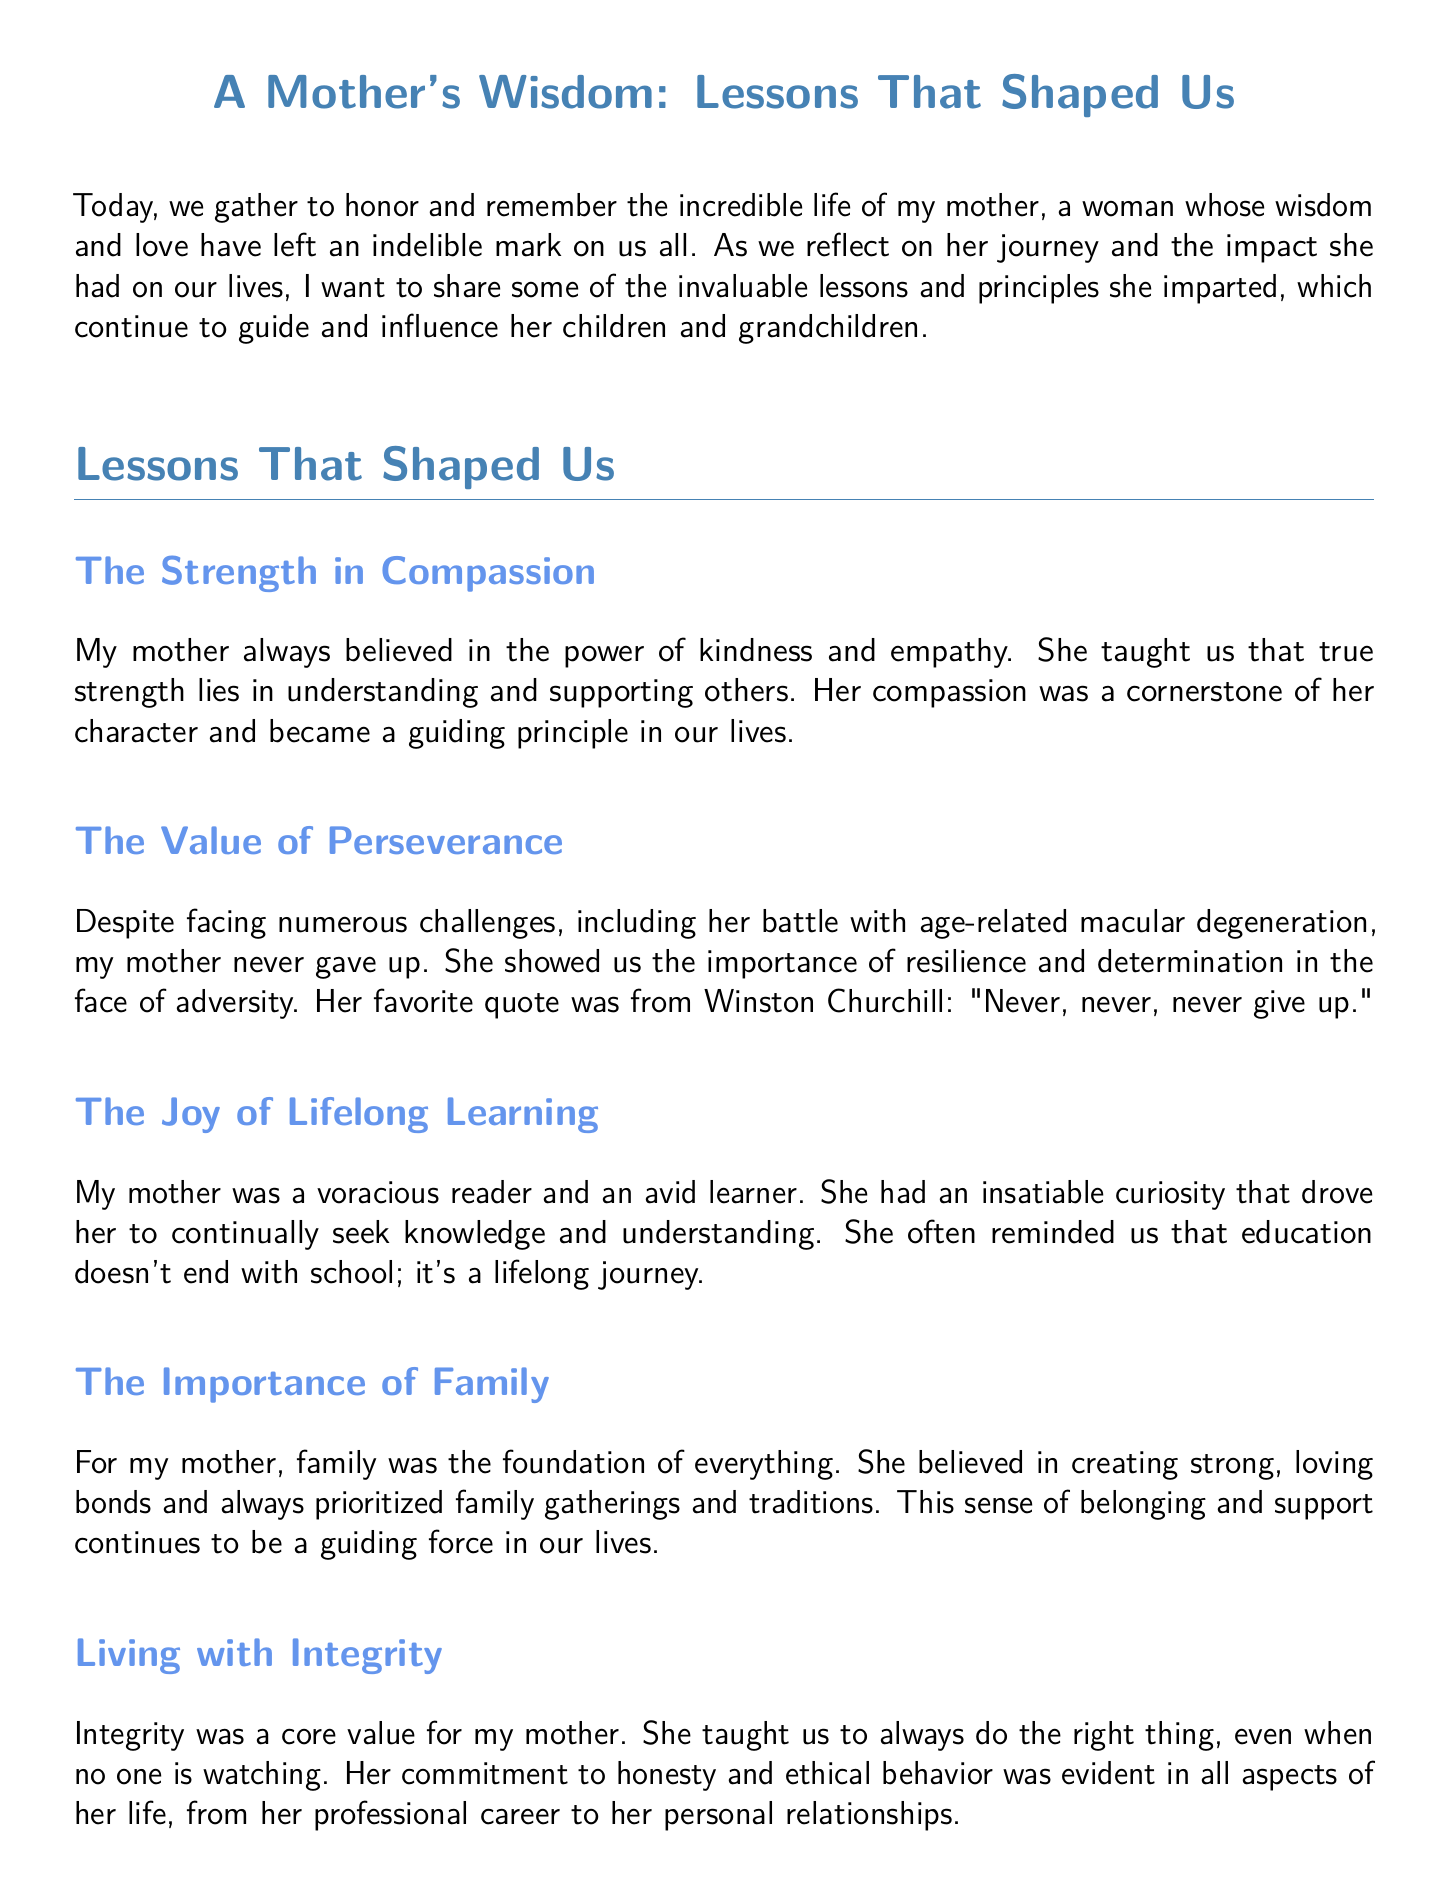What is the title of the document? The title is stated at the beginning of the document, introducing the eulogy's theme.
Answer: A Mother's Wisdom: Lessons That Shaped Us What is one principle that my mother taught us? The document lists several principles, one of which is mentioned first under the section "Lessons That Shaped Us."
Answer: The Strength in Compassion Who is quoted in the document? The document references a famous quote by a significant historical figure to emphasize a lesson.
Answer: Winston Churchill What value did my mother prioritize in her family? The document mentions that my mother believed in something fundamental concerning family relationships.
Answer: The Importance of Family What character trait was highlighted as a core value? A specific moral principle is discussed as being crucial to my mother’s life and teachings.
Answer: Integrity What is a lesson related to challenges? The document addresses how my mother dealt with difficulties and what she conveyed regarding resilience.
Answer: The Value of Perseverance What was my mother's approach to learning? The document outlines her attitude towards acquiring knowledge throughout her life.
Answer: The Joy of Lifelong Learning How does the document conclude? The ending reflects on how her lessons and values will continue to impact her loved ones.
Answer: Honor her memory 